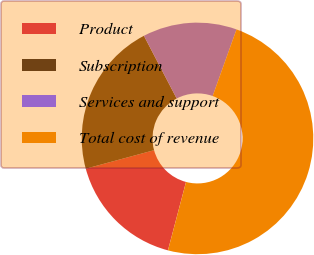Convert chart. <chart><loc_0><loc_0><loc_500><loc_500><pie_chart><fcel>Product<fcel>Subscription<fcel>Services and support<fcel>Total cost of revenue<nl><fcel>16.68%<fcel>21.55%<fcel>13.13%<fcel>48.64%<nl></chart> 